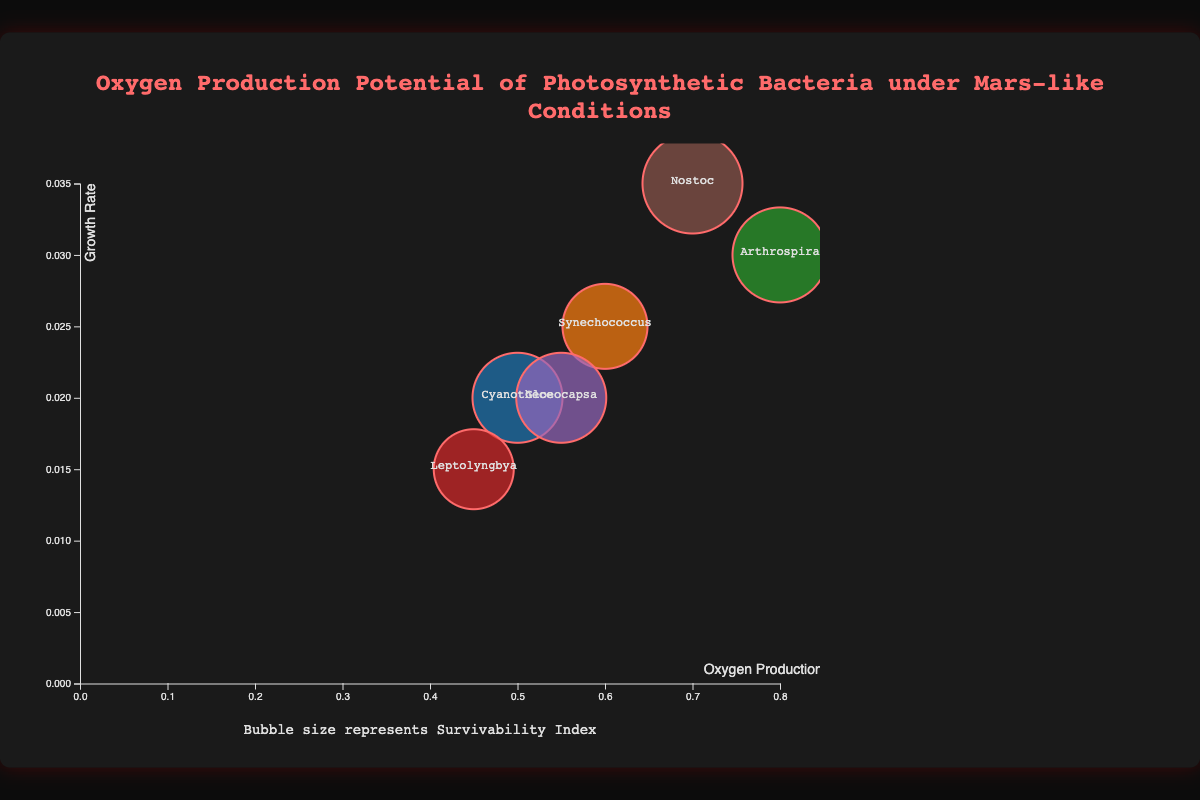What is the title of the chart? The title of the chart is located at the top and is visually distinctive due to its size and color. This helps to identify the purpose of the chart.
Answer: Oxygen Production Potential of Photosynthetic Bacteria under Mars-like Conditions How many species of photosynthetic bacteria are represented in the chart? The chart shows one bubble for each species and the labels are clearly visible within or near each bubble. Counting these labels gives the total number of species.
Answer: 6 Which species has the highest oxygen production rate? By examining the x-axis and looking for the species with the bubble furthest to the right, we can identify which species has the highest oxygen production rate.
Answer: Arthrospira What is the relationship between growth rate and oxygen production rate for the species Nostoc? Locate the bubble representing Nostoc, then check its position on the x-axis to determine the oxygen production rate and on the y-axis for the growth rate.
Answer: Oxygen production rate: 0.7, Growth rate: 0.035 Compare the survivability index of Gloeocapsa and Nostoc. Which one is higher? Identify the bubbles for Gloeocapsa and Nostoc. The size of the bubbles represents the survivability index. Compare the sizes to determine which is larger.
Answer: Nostoc Which species has the lowest growth rate and what is its oxygen production rate? Find the bubble closest to the bottom on the y-axis (growth rate). Check the corresponding x-axis position for its oxygen production rate.
Answer: Leptolyngbya, 0.45 Among the species with a survivability index of 0.7, which one has a higher oxygen production rate? Identify the species with bubble sizes corresponding to a survivability index of 0.7. Compare their positions on the x-axis to find which one has a higher oxygen production rate.
Answer: Cyanothece Which species has the highest growth rate? Locate the bubble positioned highest on the y-axis. The label within or near this bubble indicates the species with the highest growth rate.
Answer: Nostoc What is the average oxygen production rate of all the species? Sum the oxygen production rates of all the species and divide by the total number of species: (0.5 + 0.6 + 0.8 + 0.45 + 0.55 + 0.7) / 6.
Answer: 0.6 Compare Synechococcus and Leptolyngbya in terms of their oxygen production rate and growth rate. Which one has higher values for both metrics? Check the positions of Synechococcus and Leptolyngbya bubbles on the x-axis for oxygen production rate and on the y-axis for growth rate. Compare these values directly.
Answer: Synechococcus 